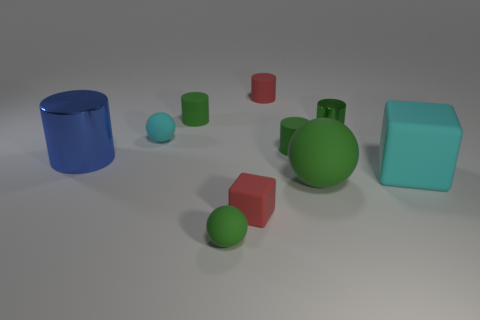Is there an object that stands out from the rest due to its color? Yes, the red cube is particularly striking. It stands out due to its vivid color, which contrasts with the more subdued tones of the other objects in the image. 